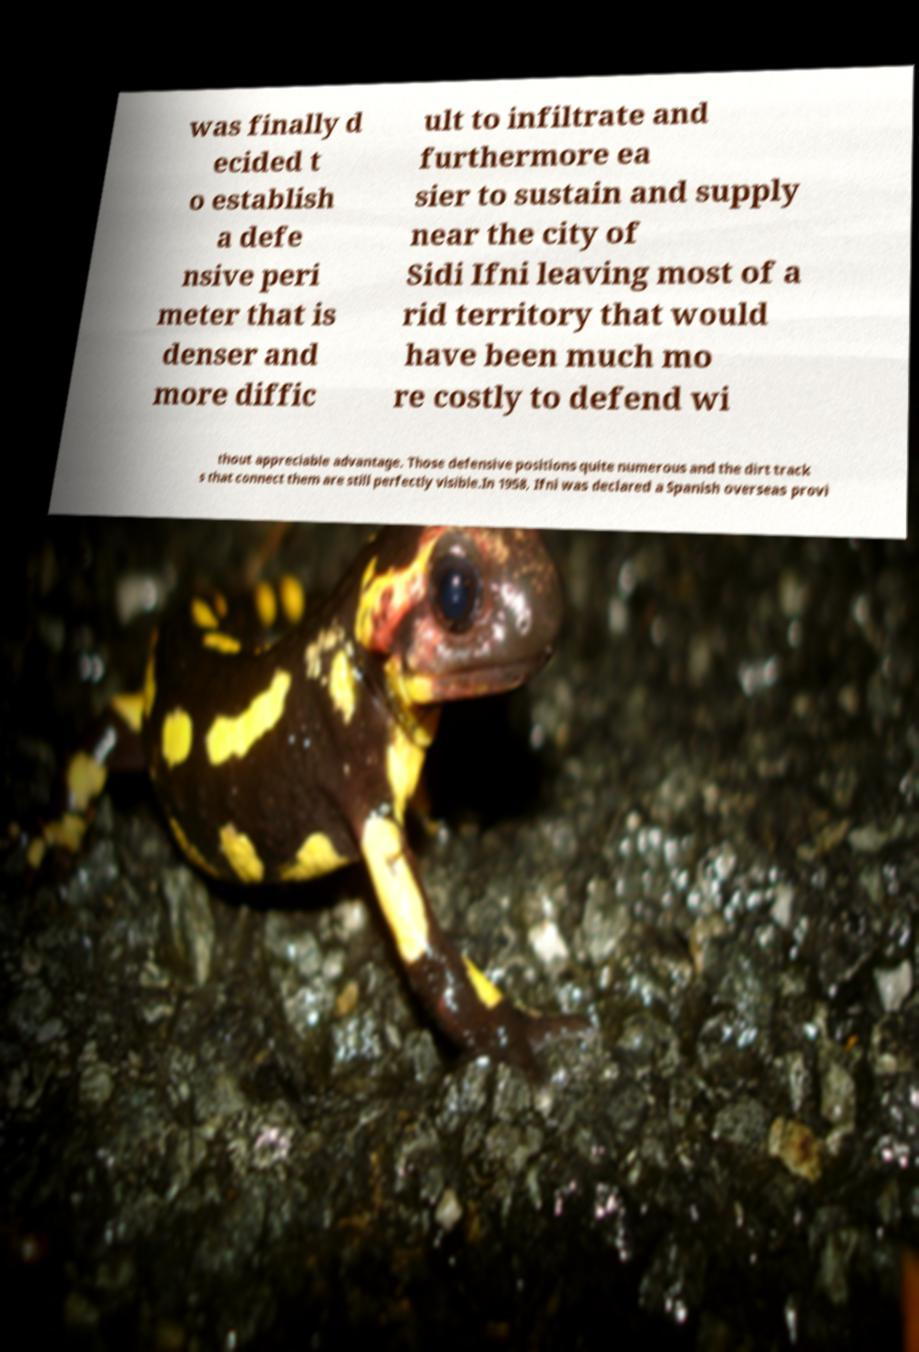Please read and relay the text visible in this image. What does it say? was finally d ecided t o establish a defe nsive peri meter that is denser and more diffic ult to infiltrate and furthermore ea sier to sustain and supply near the city of Sidi Ifni leaving most of a rid territory that would have been much mo re costly to defend wi thout appreciable advantage. Those defensive positions quite numerous and the dirt track s that connect them are still perfectly visible.In 1958, Ifni was declared a Spanish overseas provi 